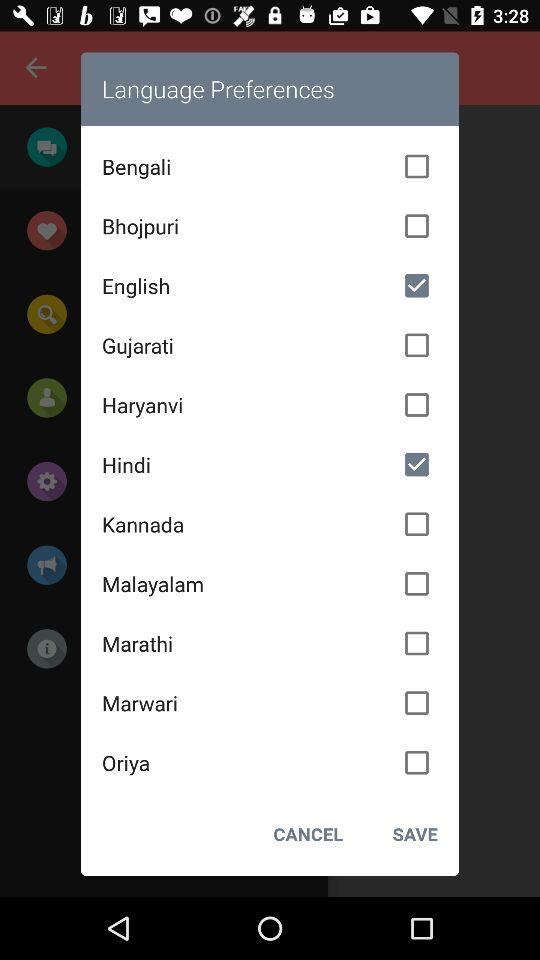Which option was selected? The selected options were "English" and "Hindi". 